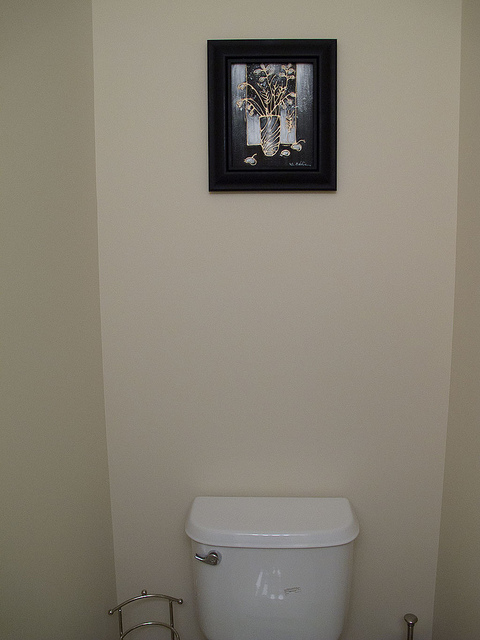Could you describe the color scheme of the room? The room features a neutral color scheme with light beige walls that complement the white fixtures. Does the room have any textures or patterns? Aside from the still-life image in the frame, the room's surfaces are smooth and solid-colored, lacking any distinct textures or patterns. 